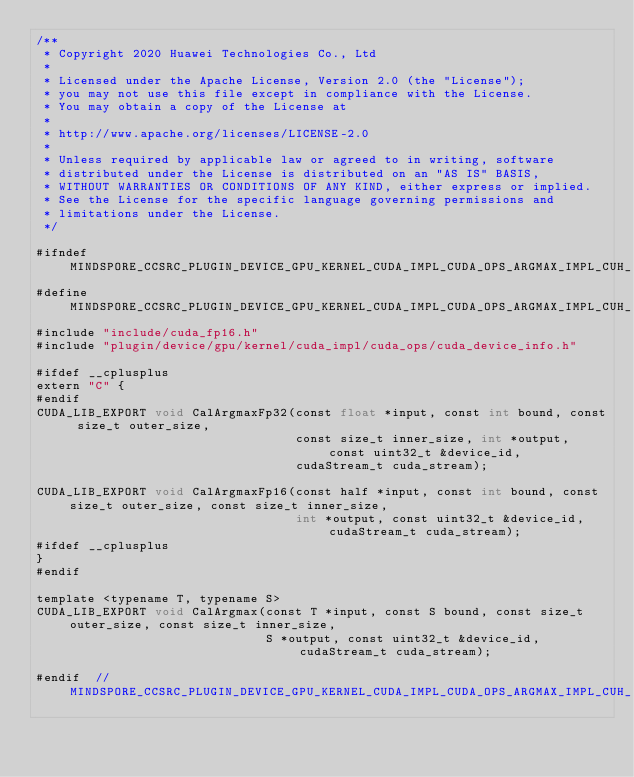<code> <loc_0><loc_0><loc_500><loc_500><_Cuda_>/**
 * Copyright 2020 Huawei Technologies Co., Ltd
 *
 * Licensed under the Apache License, Version 2.0 (the "License");
 * you may not use this file except in compliance with the License.
 * You may obtain a copy of the License at
 *
 * http://www.apache.org/licenses/LICENSE-2.0
 *
 * Unless required by applicable law or agreed to in writing, software
 * distributed under the License is distributed on an "AS IS" BASIS,
 * WITHOUT WARRANTIES OR CONDITIONS OF ANY KIND, either express or implied.
 * See the License for the specific language governing permissions and
 * limitations under the License.
 */

#ifndef MINDSPORE_CCSRC_PLUGIN_DEVICE_GPU_KERNEL_CUDA_IMPL_CUDA_OPS_ARGMAX_IMPL_CUH_
#define MINDSPORE_CCSRC_PLUGIN_DEVICE_GPU_KERNEL_CUDA_IMPL_CUDA_OPS_ARGMAX_IMPL_CUH_
#include "include/cuda_fp16.h"
#include "plugin/device/gpu/kernel/cuda_impl/cuda_ops/cuda_device_info.h"

#ifdef __cplusplus
extern "C" {
#endif
CUDA_LIB_EXPORT void CalArgmaxFp32(const float *input, const int bound, const size_t outer_size,
                                   const size_t inner_size, int *output, const uint32_t &device_id,
                                   cudaStream_t cuda_stream);

CUDA_LIB_EXPORT void CalArgmaxFp16(const half *input, const int bound, const size_t outer_size, const size_t inner_size,
                                   int *output, const uint32_t &device_id, cudaStream_t cuda_stream);
#ifdef __cplusplus
}
#endif

template <typename T, typename S>
CUDA_LIB_EXPORT void CalArgmax(const T *input, const S bound, const size_t outer_size, const size_t inner_size,
                               S *output, const uint32_t &device_id, cudaStream_t cuda_stream);

#endif  // MINDSPORE_CCSRC_PLUGIN_DEVICE_GPU_KERNEL_CUDA_IMPL_CUDA_OPS_ARGMAX_IMPL_CUH_
</code> 